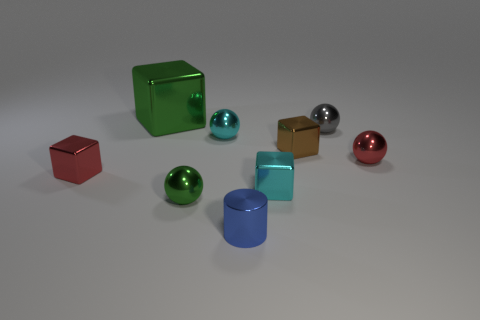What is the size of the metallic ball behind the tiny cyan thing to the left of the blue cylinder?
Your response must be concise. Small. There is a block that is both to the right of the metallic cylinder and behind the red ball; what color is it?
Give a very brief answer. Brown. Is the tiny green shiny object the same shape as the tiny gray metallic thing?
Your response must be concise. Yes. What is the size of the other thing that is the same color as the big shiny thing?
Provide a short and direct response. Small. Are there an equal number of cyan cubes and blue metallic spheres?
Give a very brief answer. No. There is a green metal thing that is behind the small cyan metal thing on the left side of the tiny cylinder; what shape is it?
Provide a succinct answer. Cube. There is a tiny brown object; is it the same shape as the cyan metallic object that is behind the tiny red metal cube?
Your response must be concise. No. There is a metallic cylinder that is the same size as the cyan block; what color is it?
Provide a succinct answer. Blue. Are there fewer tiny blue shiny objects to the right of the brown thing than cyan balls that are behind the gray metal sphere?
Provide a succinct answer. No. What shape is the object to the left of the green shiny object that is behind the cyan object that is on the left side of the tiny blue metal cylinder?
Offer a very short reply. Cube. 